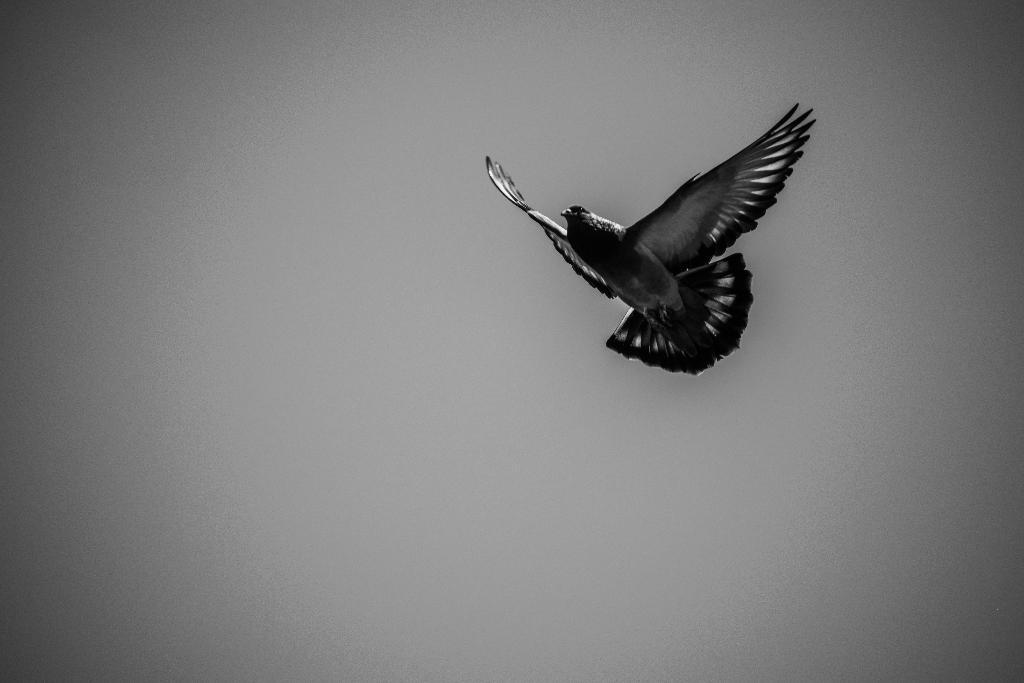What type of animal can be seen in the image? There is a bird in the image. What is the bird doing in the image? The bird is flying. Where is the zebra located in the image? There is no zebra present in the image; it only features a bird that is flying. 